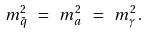<formula> <loc_0><loc_0><loc_500><loc_500>m ^ { 2 } _ { \tilde { q } } \ = \ m ^ { 2 } _ { a } \ = \ m ^ { 2 } _ { \gamma } \, .</formula> 